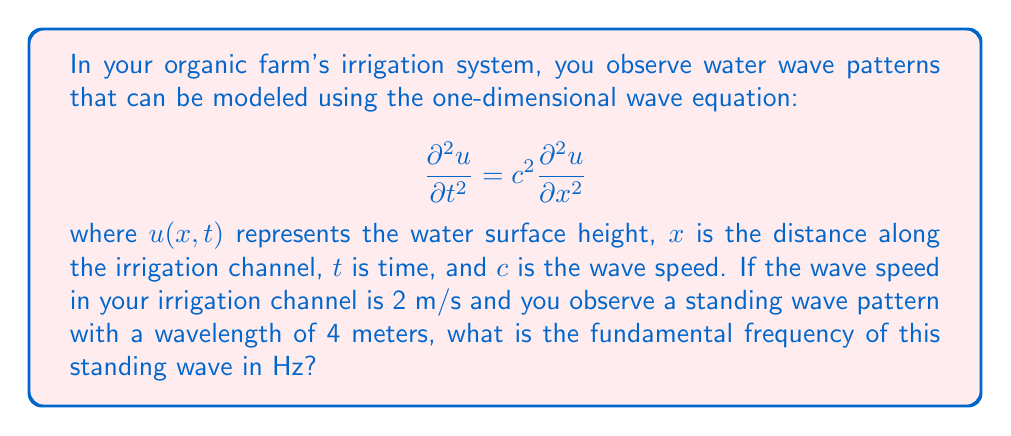What is the answer to this math problem? To solve this problem, we'll follow these steps:

1) Recall the relationship between wavelength ($\lambda$), frequency ($f$), and wave speed ($c$):

   $$c = \lambda f$$

2) We're given the wave speed $c = 2$ m/s and the wavelength $\lambda = 4$ m.

3) Rearrange the equation to solve for frequency:

   $$f = \frac{c}{\lambda}$$

4) Substitute the known values:

   $$f = \frac{2 \text{ m/s}}{4 \text{ m}}$$

5) Calculate:

   $$f = 0.5 \text{ Hz}$$

6) However, this is the frequency of a traveling wave. For a standing wave, the fundamental frequency is half of this value because a standing wave forms when two traveling waves moving in opposite directions interfere.

7) Therefore, the fundamental frequency of the standing wave is:

   $$f_{\text{fundamental}} = \frac{0.5 \text{ Hz}}{2} = 0.25 \text{ Hz}$$
Answer: 0.25 Hz 